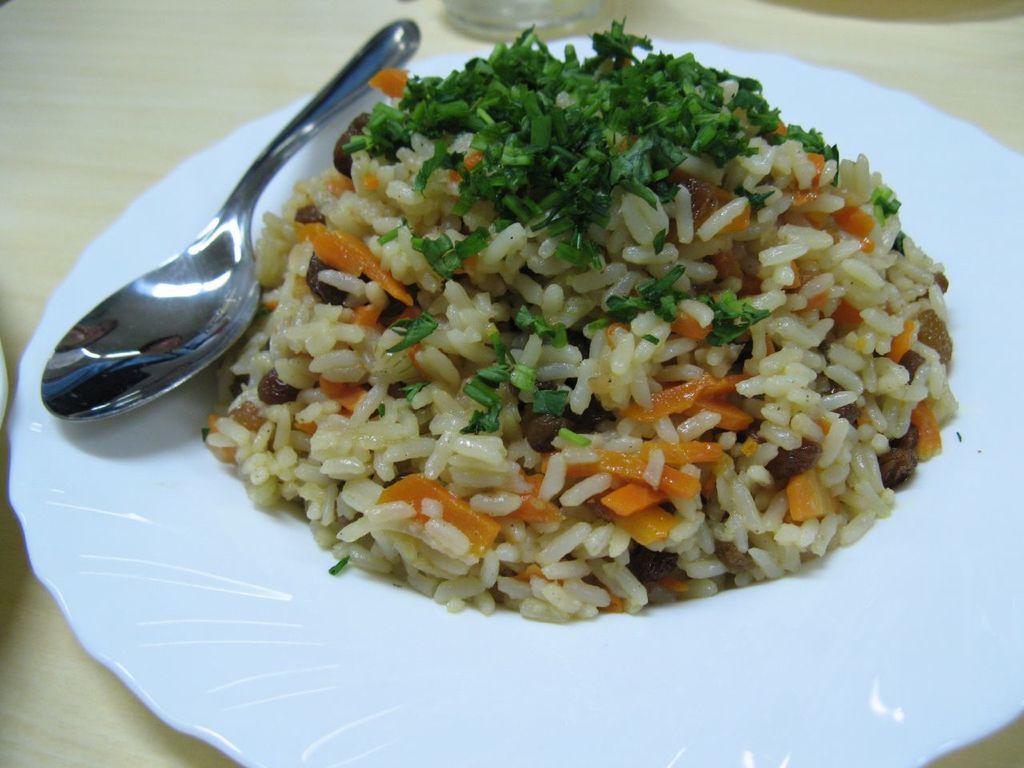Could you give a brief overview of what you see in this image? In the center of the image there is a table. On the table we can see glass, plate of food item with spoon are there. 